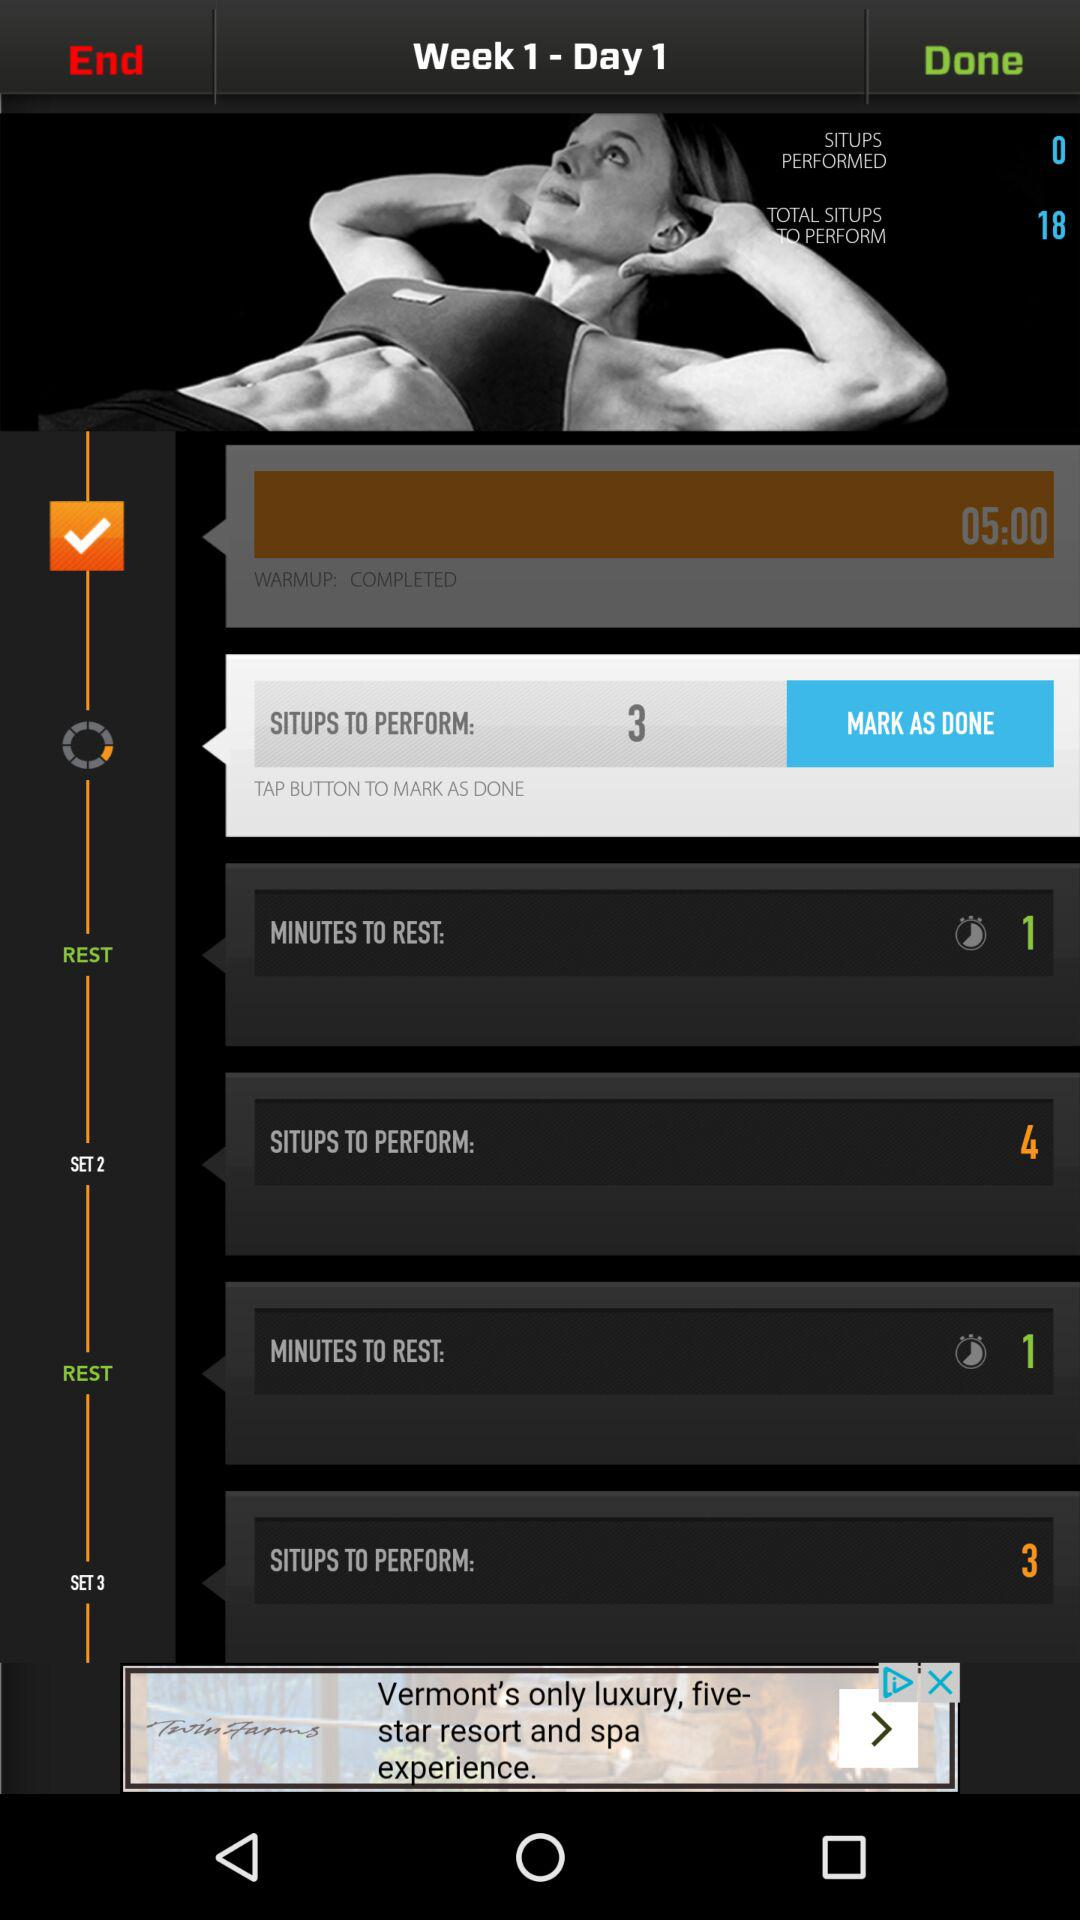How many more situps are left to perform than have been performed?
Answer the question using a single word or phrase. 18 